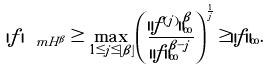Convert formula to latex. <formula><loc_0><loc_0><loc_500><loc_500>| f | _ { \ m H ^ { \beta } } \geq \max _ { 1 \leq j \leq \lfloor \beta \rfloor } \left ( \frac { \| f ^ { ( j ) } \| _ { \infty } ^ { \beta } } { \| f \| _ { \infty } ^ { \beta - j } } \right ) ^ { \frac { 1 } { j } } \geq \| f \| _ { \infty } .</formula> 